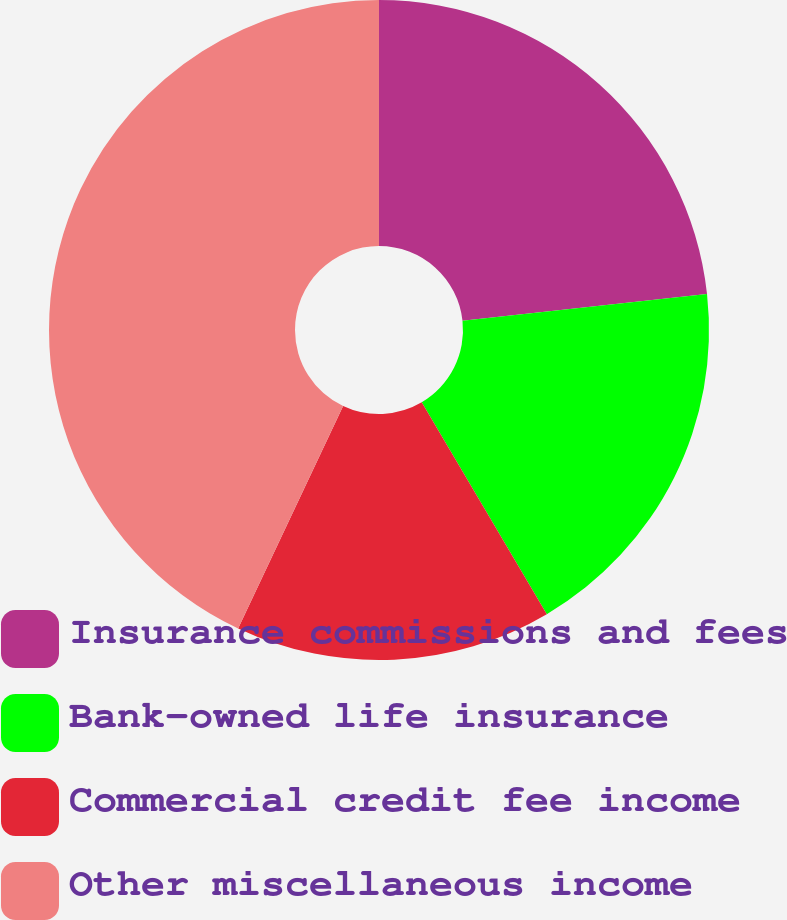Convert chart. <chart><loc_0><loc_0><loc_500><loc_500><pie_chart><fcel>Insurance commissions and fees<fcel>Bank-owned life insurance<fcel>Commercial credit fee income<fcel>Other miscellaneous income<nl><fcel>23.26%<fcel>18.25%<fcel>15.51%<fcel>42.98%<nl></chart> 